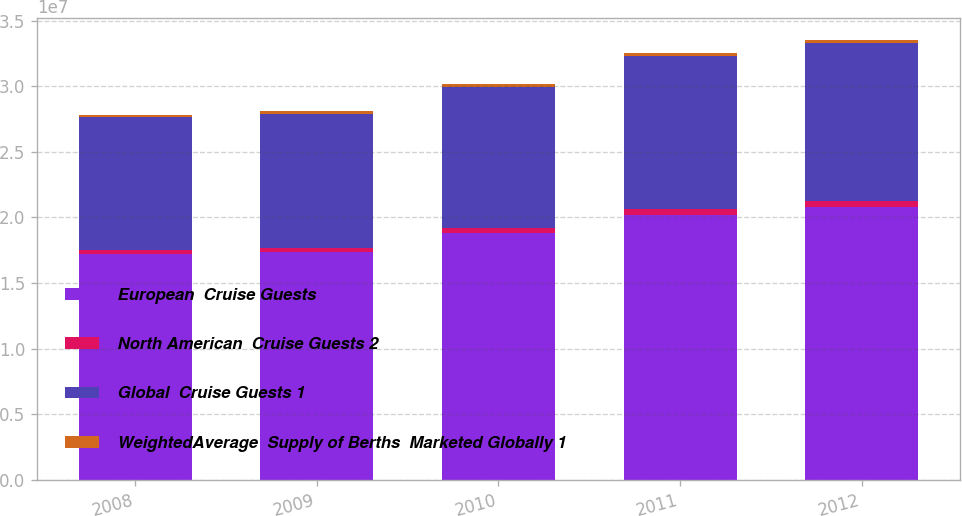Convert chart. <chart><loc_0><loc_0><loc_500><loc_500><stacked_bar_chart><ecel><fcel>2008<fcel>2009<fcel>2010<fcel>2011<fcel>2012<nl><fcel>European  Cruise Guests<fcel>1.7184e+07<fcel>1.734e+07<fcel>1.88e+07<fcel>2.0227e+07<fcel>2.0823e+07<nl><fcel>North American  Cruise Guests 2<fcel>347000<fcel>363000<fcel>391000<fcel>412000<fcel>425000<nl><fcel>Global  Cruise Guests 1<fcel>1.0093e+07<fcel>1.0198e+07<fcel>1.0781e+07<fcel>1.1625e+07<fcel>1.2044e+07<nl><fcel>WeightedAverage  Supply of Berths  Marketed Globally 1<fcel>219000<fcel>222000<fcel>232000<fcel>245000<fcel>254000<nl></chart> 